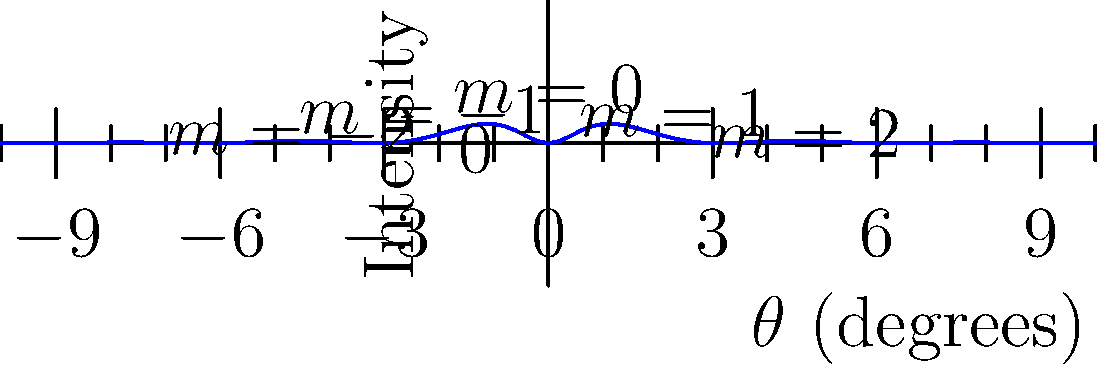In the X-ray diffraction pattern shown above, what physical parameter does the spacing between adjacent peaks correspond to, and how might this information be useful in synthetic tissue engineering? 1. The graph shows an X-ray diffraction pattern, where intensity is plotted against the diffraction angle $\theta$.

2. The spacing between adjacent peaks in the pattern corresponds to the interplanar spacing in the crystal lattice, denoted as $d$.

3. This relationship is described by Bragg's Law: $n\lambda = 2d\sin\theta$, where:
   - $n$ is the order of diffraction (integer)
   - $\lambda$ is the wavelength of the X-rays
   - $d$ is the interplanar spacing
   - $\theta$ is the diffraction angle

4. The spacing between peaks ($\Delta\theta$) is inversely proportional to the interplanar spacing $d$.

5. In synthetic tissue engineering, this information can be used to:
   a) Determine the molecular structure of engineered tissues
   b) Assess the alignment and organization of collagen fibers
   c) Monitor the formation of crystalline structures in biomineralization processes
   d) Evaluate the success of tissue scaffold designs in mimicking natural tissue structures

6. By analyzing the diffraction pattern, researchers can ensure that engineered tissues closely resemble the structural characteristics of natural tissues, improving their functionality and integration.
Answer: Interplanar spacing in the crystal lattice; used to assess molecular structure and organization in engineered tissues. 